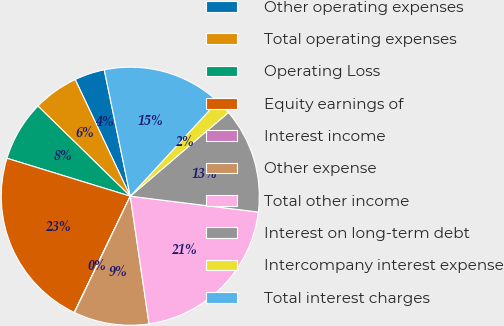Convert chart. <chart><loc_0><loc_0><loc_500><loc_500><pie_chart><fcel>Other operating expenses<fcel>Total operating expenses<fcel>Operating Loss<fcel>Equity earnings of<fcel>Interest income<fcel>Other expense<fcel>Total other income<fcel>Interest on long-term debt<fcel>Intercompany interest expense<fcel>Total interest charges<nl><fcel>3.79%<fcel>5.67%<fcel>7.56%<fcel>22.6%<fcel>0.03%<fcel>9.44%<fcel>20.72%<fcel>13.2%<fcel>1.91%<fcel>15.08%<nl></chart> 